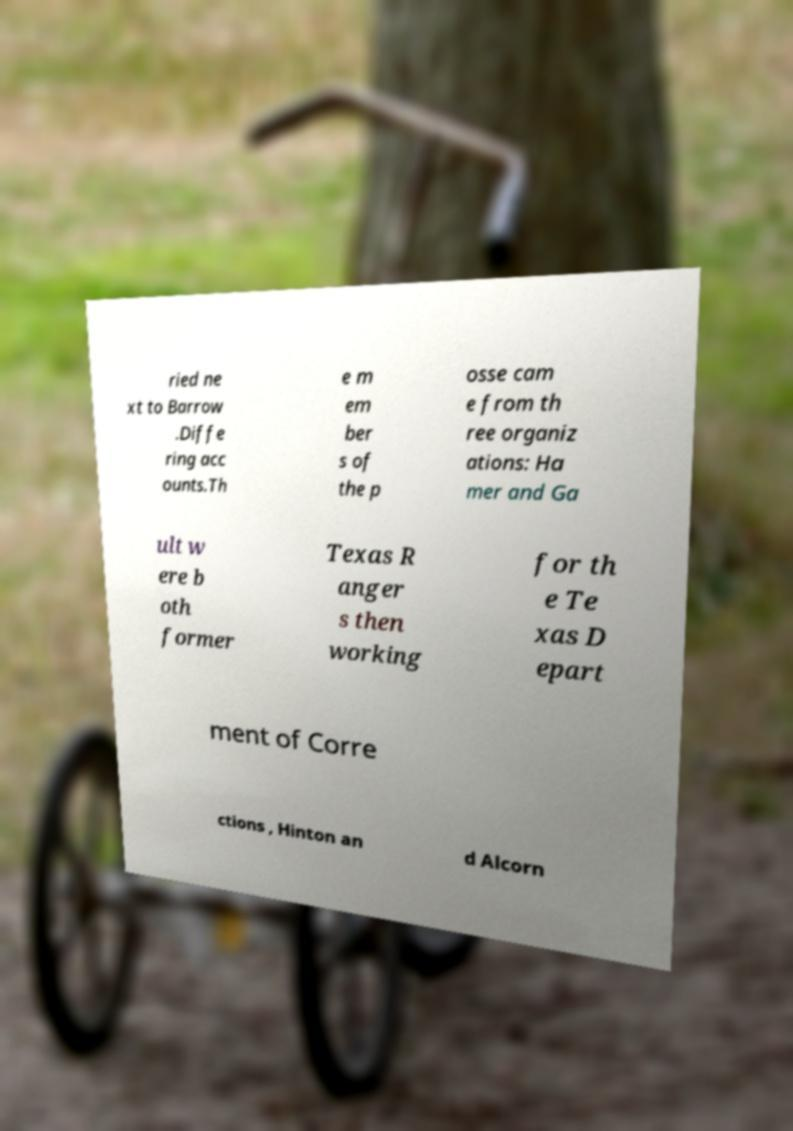Please read and relay the text visible in this image. What does it say? ried ne xt to Barrow .Diffe ring acc ounts.Th e m em ber s of the p osse cam e from th ree organiz ations: Ha mer and Ga ult w ere b oth former Texas R anger s then working for th e Te xas D epart ment of Corre ctions , Hinton an d Alcorn 